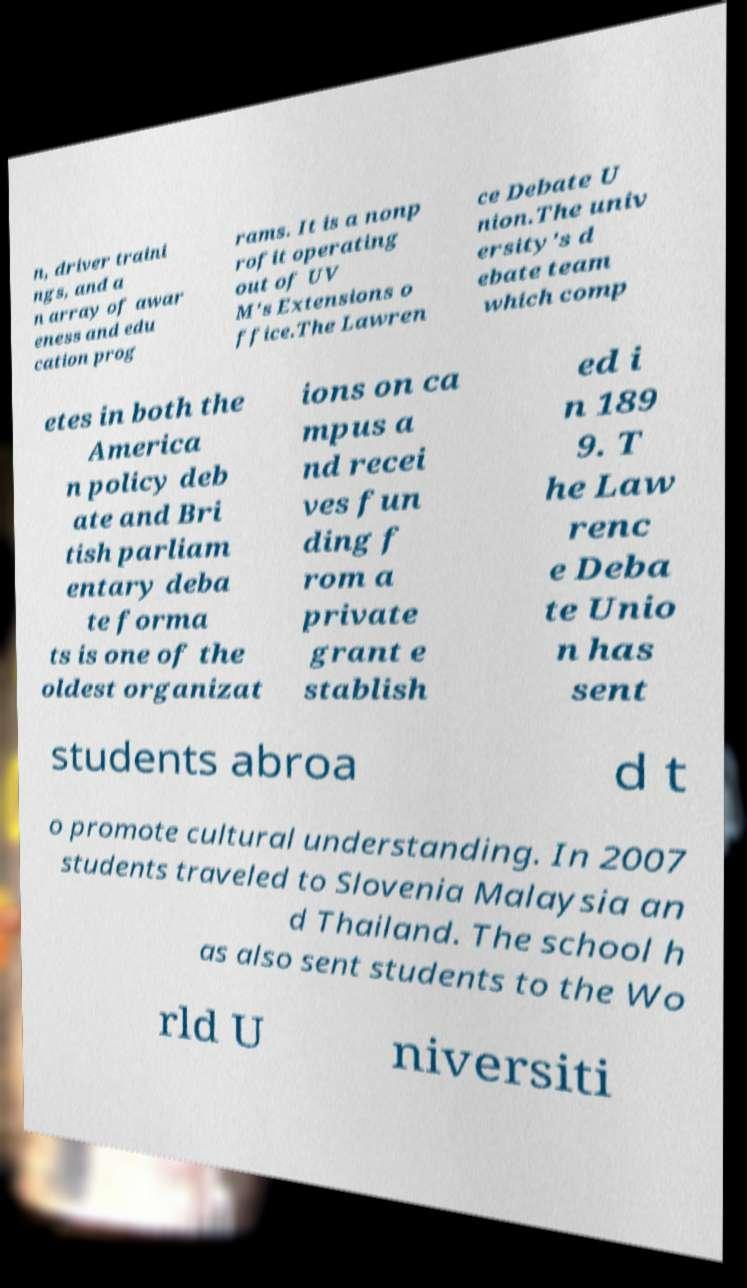What messages or text are displayed in this image? I need them in a readable, typed format. n, driver traini ngs, and a n array of awar eness and edu cation prog rams. It is a nonp rofit operating out of UV M's Extensions o ffice.The Lawren ce Debate U nion.The univ ersity's d ebate team which comp etes in both the America n policy deb ate and Bri tish parliam entary deba te forma ts is one of the oldest organizat ions on ca mpus a nd recei ves fun ding f rom a private grant e stablish ed i n 189 9. T he Law renc e Deba te Unio n has sent students abroa d t o promote cultural understanding. In 2007 students traveled to Slovenia Malaysia an d Thailand. The school h as also sent students to the Wo rld U niversiti 